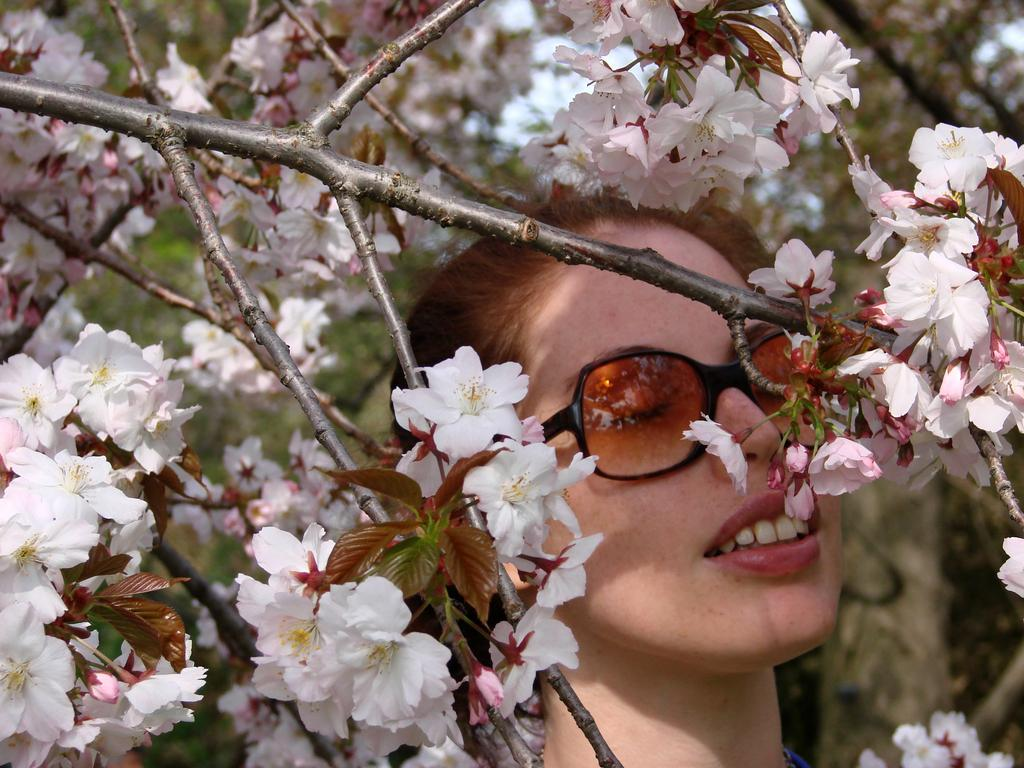Who is the main subject in the image? There is a lady in the center of the image. What is the lady wearing on her face? The lady is wearing sunglasses. What type of vegetation can be seen in the image? There are flowers around the area and trees in the background of the image. What can be seen in the sky in the image? The sky is visible in the background of the image. How does the lady turn her body in the image? The lady's body position cannot be determined from the image, as it only shows her from the front. What type of attention does the lady receive from the flowers in the image? The flowers do not interact with the lady in the image, so there is no indication of any attention being given. 